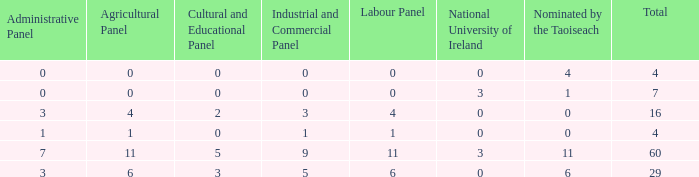What is the total number of agriculatural panels of the composition with more than 3 National Universities of Ireland? 0.0. 